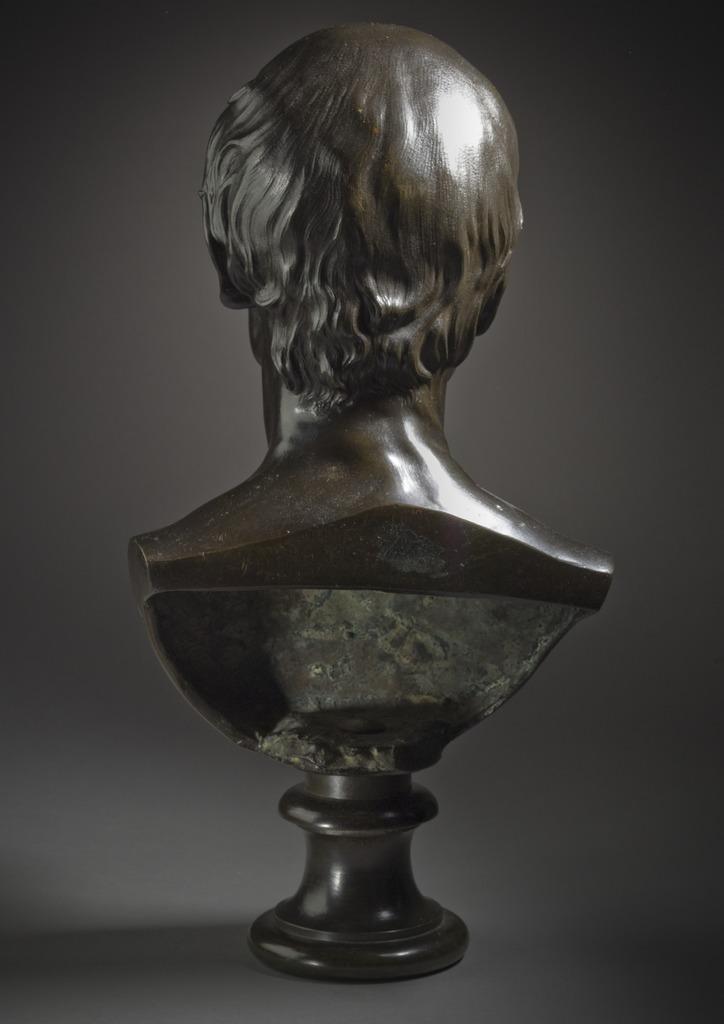Could you give a brief overview of what you see in this image? In this picture we can see a sculpture and in the background it is blurry. 